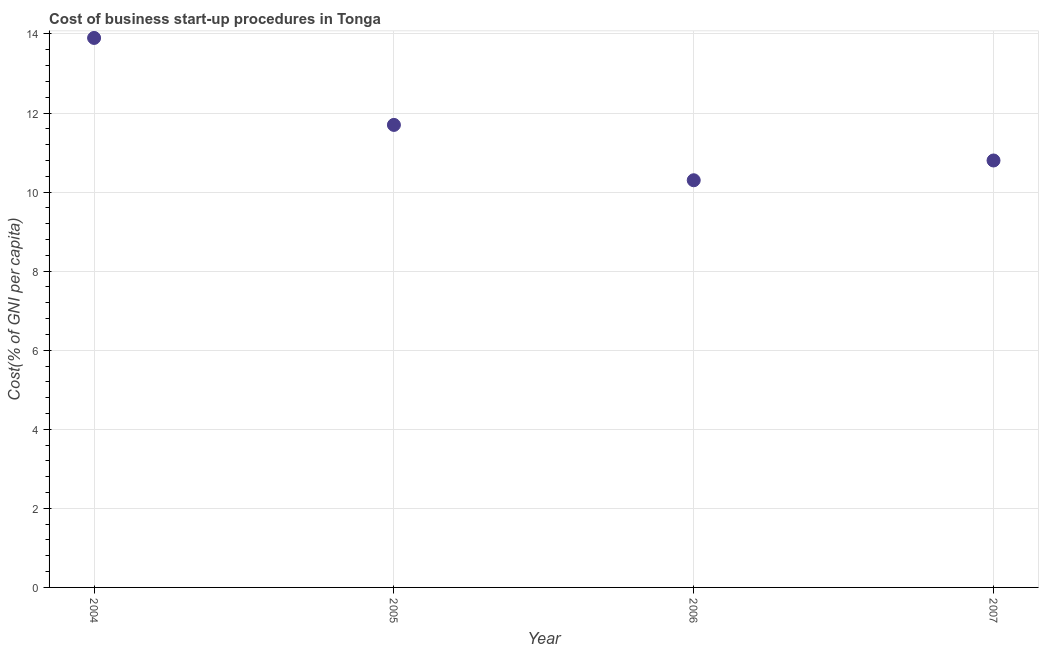Across all years, what is the minimum cost of business startup procedures?
Ensure brevity in your answer.  10.3. What is the sum of the cost of business startup procedures?
Your response must be concise. 46.7. What is the average cost of business startup procedures per year?
Make the answer very short. 11.68. What is the median cost of business startup procedures?
Your answer should be compact. 11.25. In how many years, is the cost of business startup procedures greater than 6.8 %?
Your answer should be very brief. 4. What is the ratio of the cost of business startup procedures in 2005 to that in 2006?
Your answer should be compact. 1.14. What is the difference between the highest and the second highest cost of business startup procedures?
Make the answer very short. 2.2. What is the difference between the highest and the lowest cost of business startup procedures?
Ensure brevity in your answer.  3.6. Does the cost of business startup procedures monotonically increase over the years?
Your answer should be compact. No. How many dotlines are there?
Offer a terse response. 1. How many years are there in the graph?
Provide a succinct answer. 4. What is the difference between two consecutive major ticks on the Y-axis?
Offer a very short reply. 2. Are the values on the major ticks of Y-axis written in scientific E-notation?
Provide a succinct answer. No. Does the graph contain grids?
Provide a short and direct response. Yes. What is the title of the graph?
Make the answer very short. Cost of business start-up procedures in Tonga. What is the label or title of the X-axis?
Provide a short and direct response. Year. What is the label or title of the Y-axis?
Your response must be concise. Cost(% of GNI per capita). What is the Cost(% of GNI per capita) in 2004?
Keep it short and to the point. 13.9. What is the Cost(% of GNI per capita) in 2005?
Keep it short and to the point. 11.7. What is the Cost(% of GNI per capita) in 2007?
Give a very brief answer. 10.8. What is the difference between the Cost(% of GNI per capita) in 2004 and 2005?
Provide a short and direct response. 2.2. What is the difference between the Cost(% of GNI per capita) in 2004 and 2006?
Keep it short and to the point. 3.6. What is the difference between the Cost(% of GNI per capita) in 2005 and 2006?
Ensure brevity in your answer.  1.4. What is the ratio of the Cost(% of GNI per capita) in 2004 to that in 2005?
Offer a very short reply. 1.19. What is the ratio of the Cost(% of GNI per capita) in 2004 to that in 2006?
Offer a terse response. 1.35. What is the ratio of the Cost(% of GNI per capita) in 2004 to that in 2007?
Make the answer very short. 1.29. What is the ratio of the Cost(% of GNI per capita) in 2005 to that in 2006?
Your answer should be very brief. 1.14. What is the ratio of the Cost(% of GNI per capita) in 2005 to that in 2007?
Offer a very short reply. 1.08. What is the ratio of the Cost(% of GNI per capita) in 2006 to that in 2007?
Your response must be concise. 0.95. 